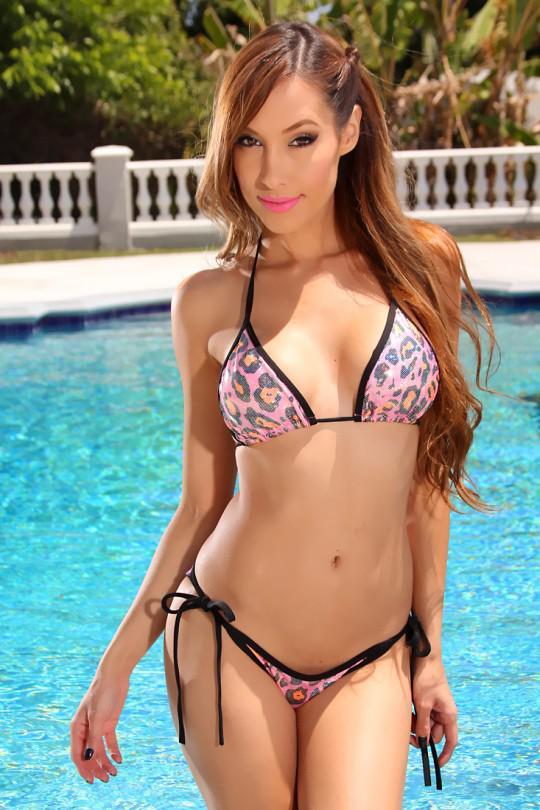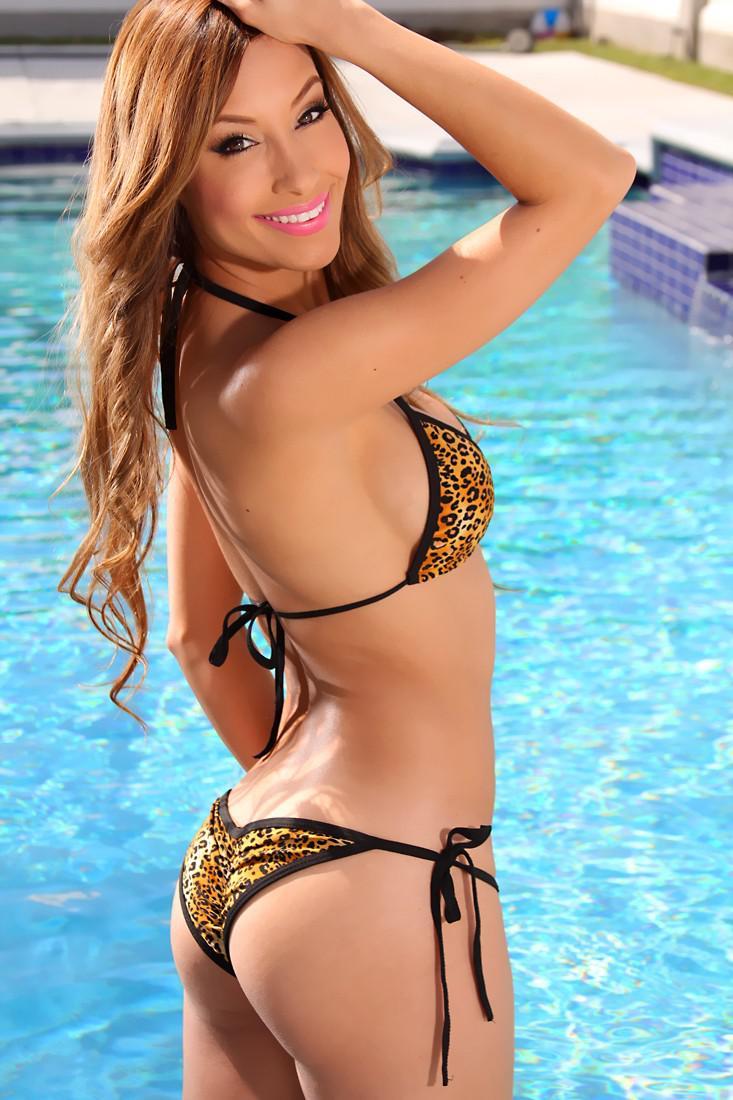The first image is the image on the left, the second image is the image on the right. Examine the images to the left and right. Is the description "The bikini in the image on the left is tied at the hip" accurate? Answer yes or no. Yes. The first image is the image on the left, the second image is the image on the right. Evaluate the accuracy of this statement regarding the images: "At least one bikini is baby blue.". Is it true? Answer yes or no. No. 